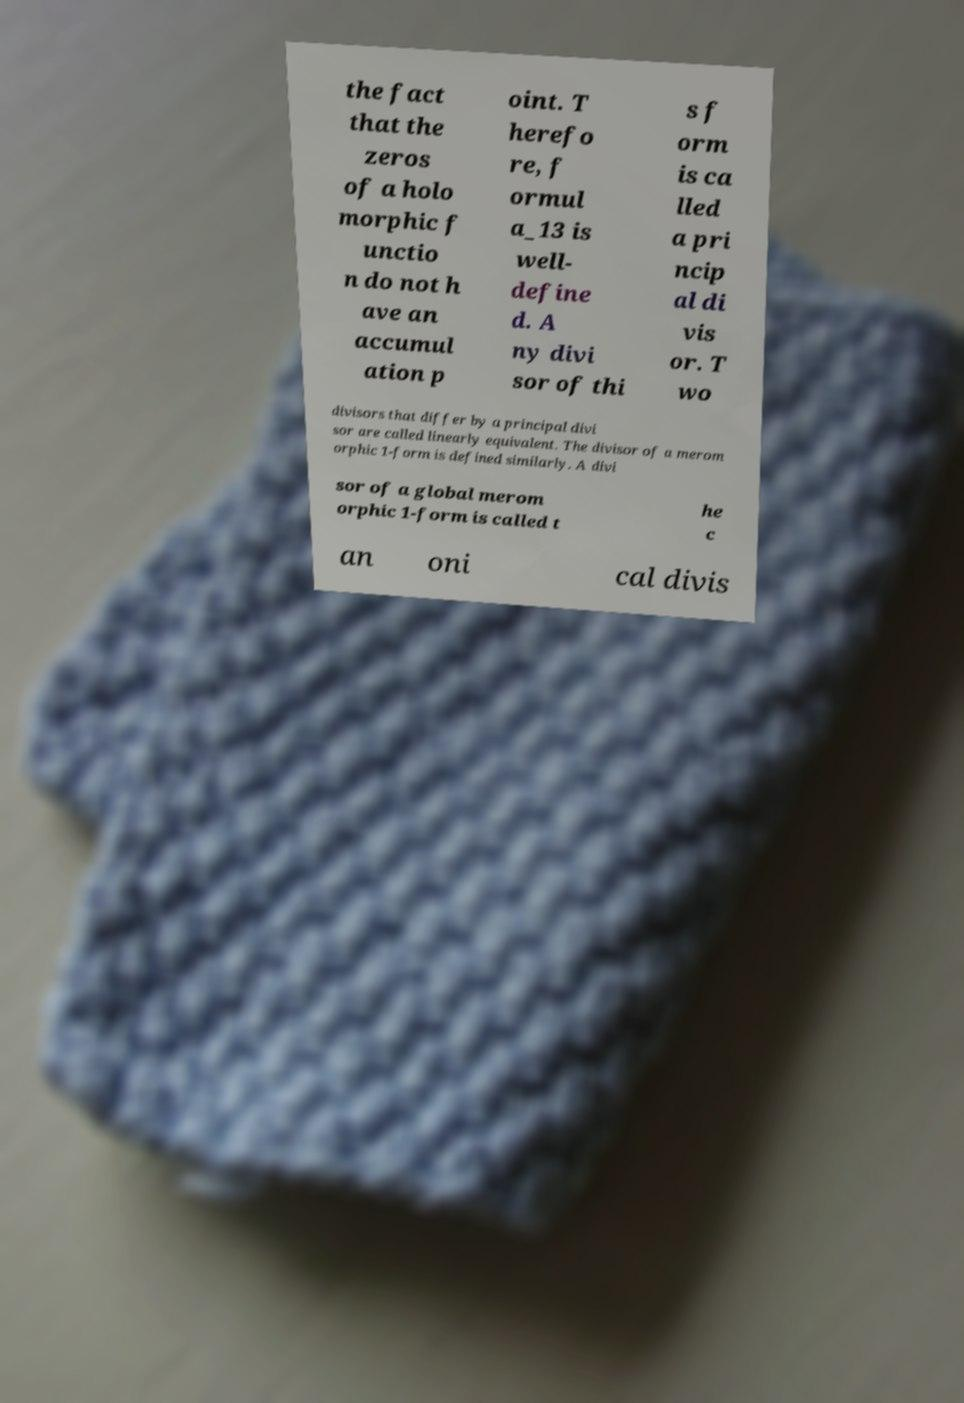What messages or text are displayed in this image? I need them in a readable, typed format. the fact that the zeros of a holo morphic f unctio n do not h ave an accumul ation p oint. T herefo re, f ormul a_13 is well- define d. A ny divi sor of thi s f orm is ca lled a pri ncip al di vis or. T wo divisors that differ by a principal divi sor are called linearly equivalent. The divisor of a merom orphic 1-form is defined similarly. A divi sor of a global merom orphic 1-form is called t he c an oni cal divis 